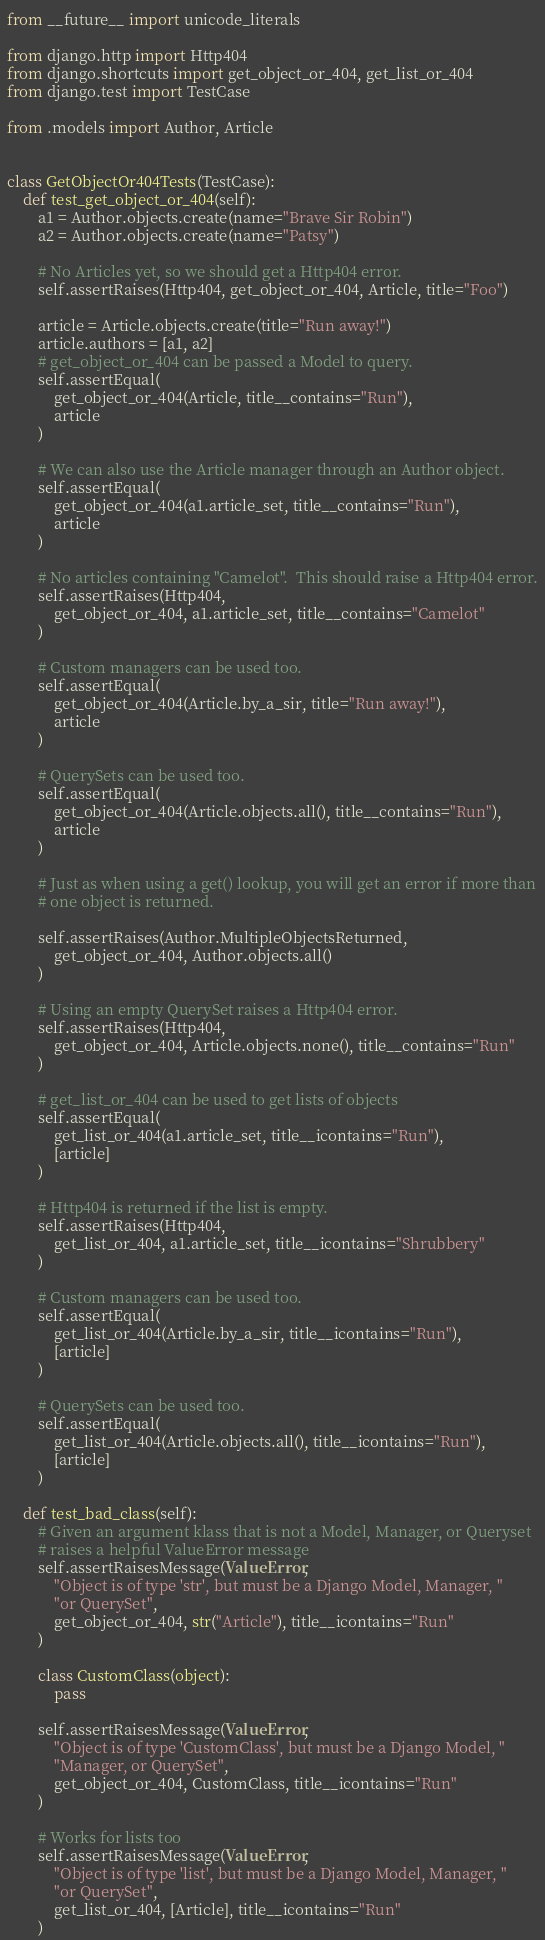Convert code to text. <code><loc_0><loc_0><loc_500><loc_500><_Python_>from __future__ import unicode_literals

from django.http import Http404
from django.shortcuts import get_object_or_404, get_list_or_404
from django.test import TestCase

from .models import Author, Article


class GetObjectOr404Tests(TestCase):
    def test_get_object_or_404(self):
        a1 = Author.objects.create(name="Brave Sir Robin")
        a2 = Author.objects.create(name="Patsy")

        # No Articles yet, so we should get a Http404 error.
        self.assertRaises(Http404, get_object_or_404, Article, title="Foo")

        article = Article.objects.create(title="Run away!")
        article.authors = [a1, a2]
        # get_object_or_404 can be passed a Model to query.
        self.assertEqual(
            get_object_or_404(Article, title__contains="Run"),
            article
        )

        # We can also use the Article manager through an Author object.
        self.assertEqual(
            get_object_or_404(a1.article_set, title__contains="Run"),
            article
        )

        # No articles containing "Camelot".  This should raise a Http404 error.
        self.assertRaises(Http404,
            get_object_or_404, a1.article_set, title__contains="Camelot"
        )

        # Custom managers can be used too.
        self.assertEqual(
            get_object_or_404(Article.by_a_sir, title="Run away!"),
            article
        )

        # QuerySets can be used too.
        self.assertEqual(
            get_object_or_404(Article.objects.all(), title__contains="Run"),
            article
        )

        # Just as when using a get() lookup, you will get an error if more than
        # one object is returned.

        self.assertRaises(Author.MultipleObjectsReturned,
            get_object_or_404, Author.objects.all()
        )

        # Using an empty QuerySet raises a Http404 error.
        self.assertRaises(Http404,
            get_object_or_404, Article.objects.none(), title__contains="Run"
        )

        # get_list_or_404 can be used to get lists of objects
        self.assertEqual(
            get_list_or_404(a1.article_set, title__icontains="Run"),
            [article]
        )

        # Http404 is returned if the list is empty.
        self.assertRaises(Http404,
            get_list_or_404, a1.article_set, title__icontains="Shrubbery"
        )

        # Custom managers can be used too.
        self.assertEqual(
            get_list_or_404(Article.by_a_sir, title__icontains="Run"),
            [article]
        )

        # QuerySets can be used too.
        self.assertEqual(
            get_list_or_404(Article.objects.all(), title__icontains="Run"),
            [article]
        )

    def test_bad_class(self):
        # Given an argument klass that is not a Model, Manager, or Queryset
        # raises a helpful ValueError message
        self.assertRaisesMessage(ValueError,
            "Object is of type 'str', but must be a Django Model, Manager, "
            "or QuerySet",
            get_object_or_404, str("Article"), title__icontains="Run"
        )

        class CustomClass(object):
            pass

        self.assertRaisesMessage(ValueError,
            "Object is of type 'CustomClass', but must be a Django Model, "
            "Manager, or QuerySet",
            get_object_or_404, CustomClass, title__icontains="Run"
        )

        # Works for lists too
        self.assertRaisesMessage(ValueError,
            "Object is of type 'list', but must be a Django Model, Manager, "
            "or QuerySet",
            get_list_or_404, [Article], title__icontains="Run"
        )
</code> 